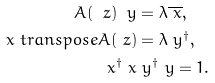<formula> <loc_0><loc_0><loc_500><loc_500>A ( \ z ) \ y & = \lambda \overline { \ x } , \\ \ x \ t r a n s p o s e A ( \ z ) & = \lambda \ y ^ { \dagger } , \\ \ x ^ { \dagger } \ x & \ y ^ { \dagger } \ y = 1 .</formula> 